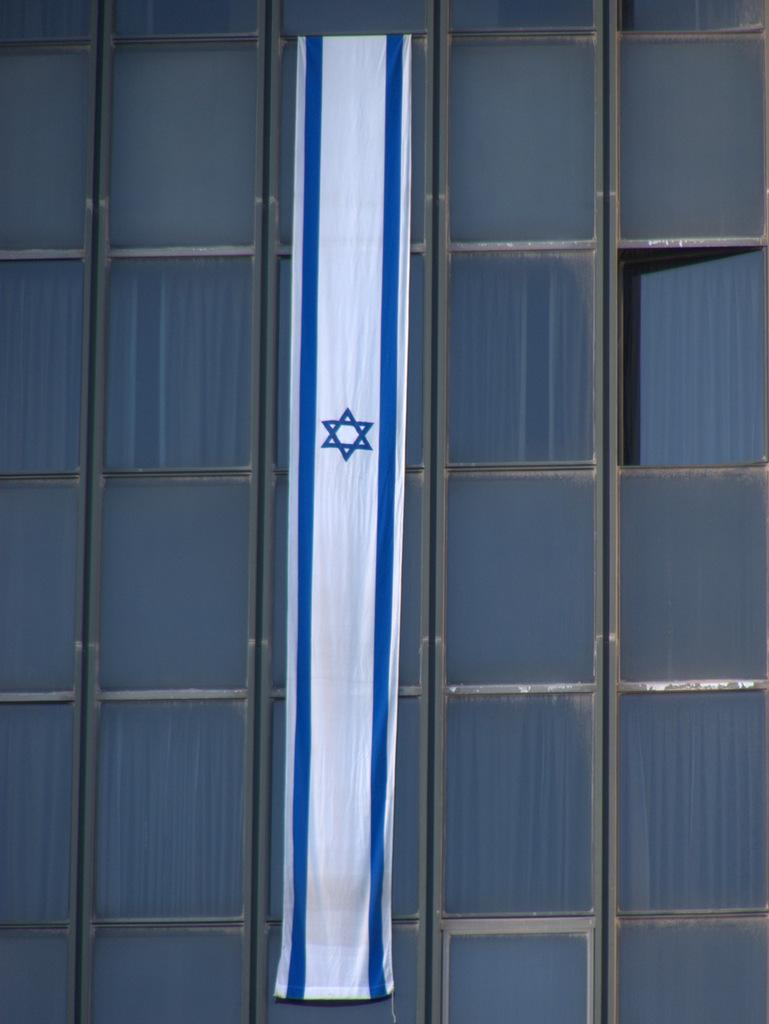What type of wall is present in the image? There is a glass wall in the image. What can be seen on the glass wall? There are objects attached to the glass wall. What type of zoo animals can be seen in the image? There is no zoo or animals present in the image; it only features a glass wall with objects attached to it. What type of book is visible on the glass wall? There is no book present in the image; it only features a glass wall with objects attached to it. 